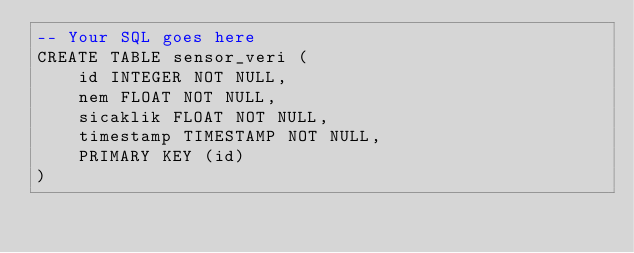<code> <loc_0><loc_0><loc_500><loc_500><_SQL_>-- Your SQL goes here
CREATE TABLE sensor_veri (
	id INTEGER NOT NULL, 
	nem FLOAT NOT NULL, 
	sicaklik FLOAT NOT NULL, 
	timestamp TIMESTAMP NOT NULL, 
	PRIMARY KEY (id)
)</code> 